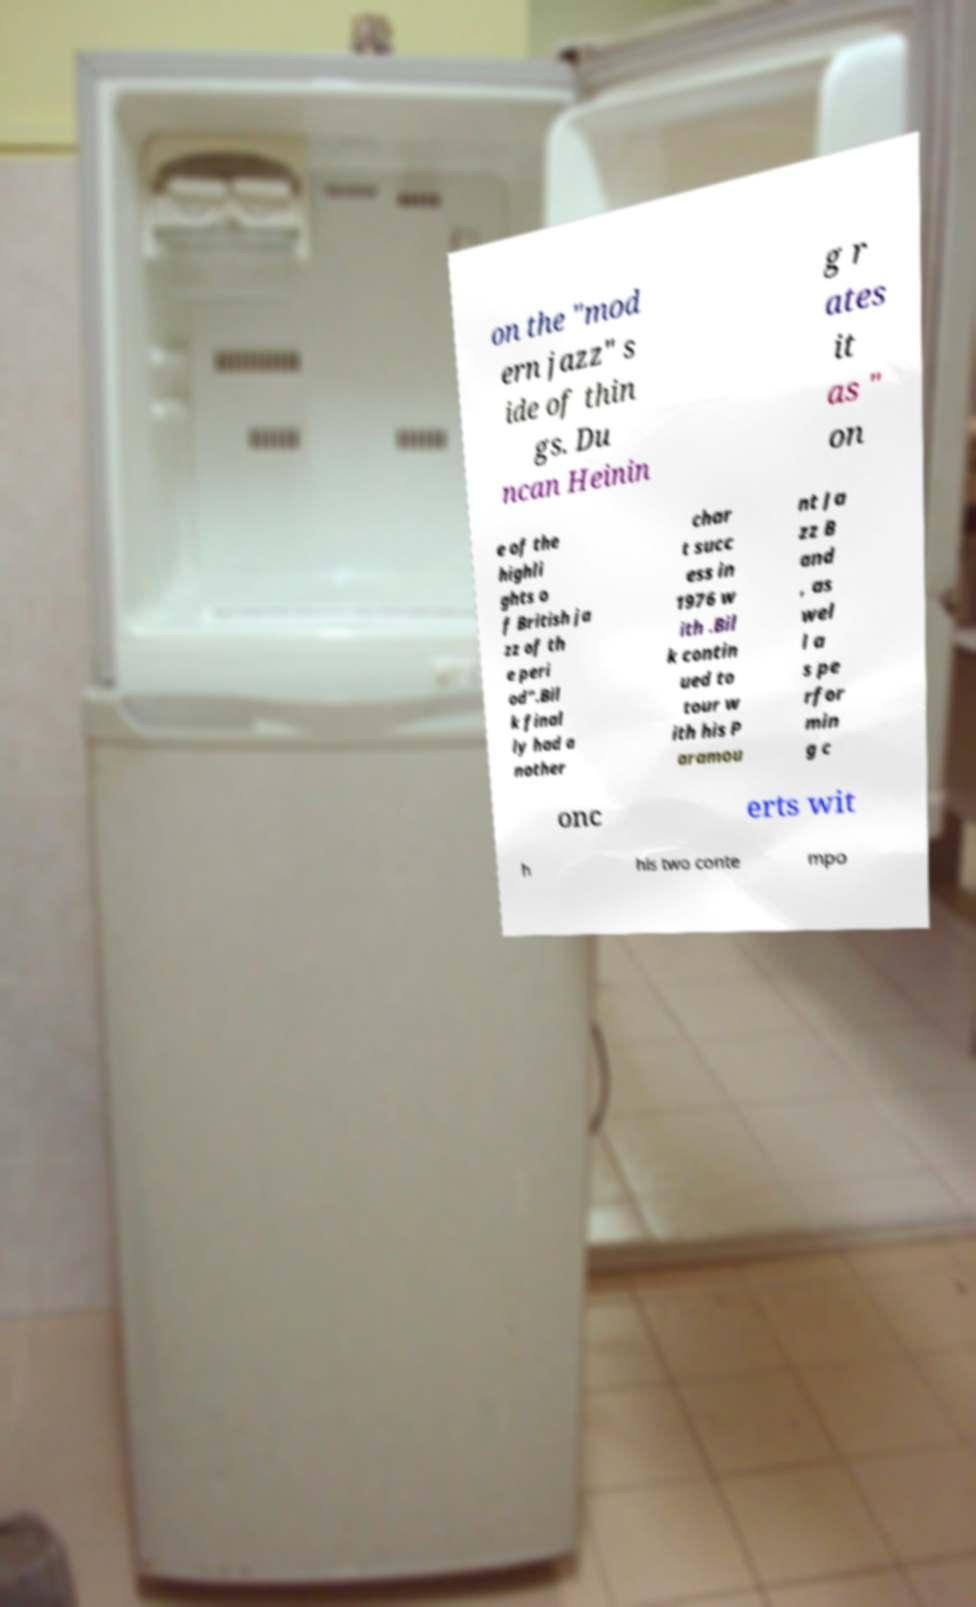For documentation purposes, I need the text within this image transcribed. Could you provide that? on the "mod ern jazz" s ide of thin gs. Du ncan Heinin g r ates it as " on e of the highli ghts o f British ja zz of th e peri od".Bil k final ly had a nother char t succ ess in 1976 w ith .Bil k contin ued to tour w ith his P aramou nt Ja zz B and , as wel l a s pe rfor min g c onc erts wit h his two conte mpo 